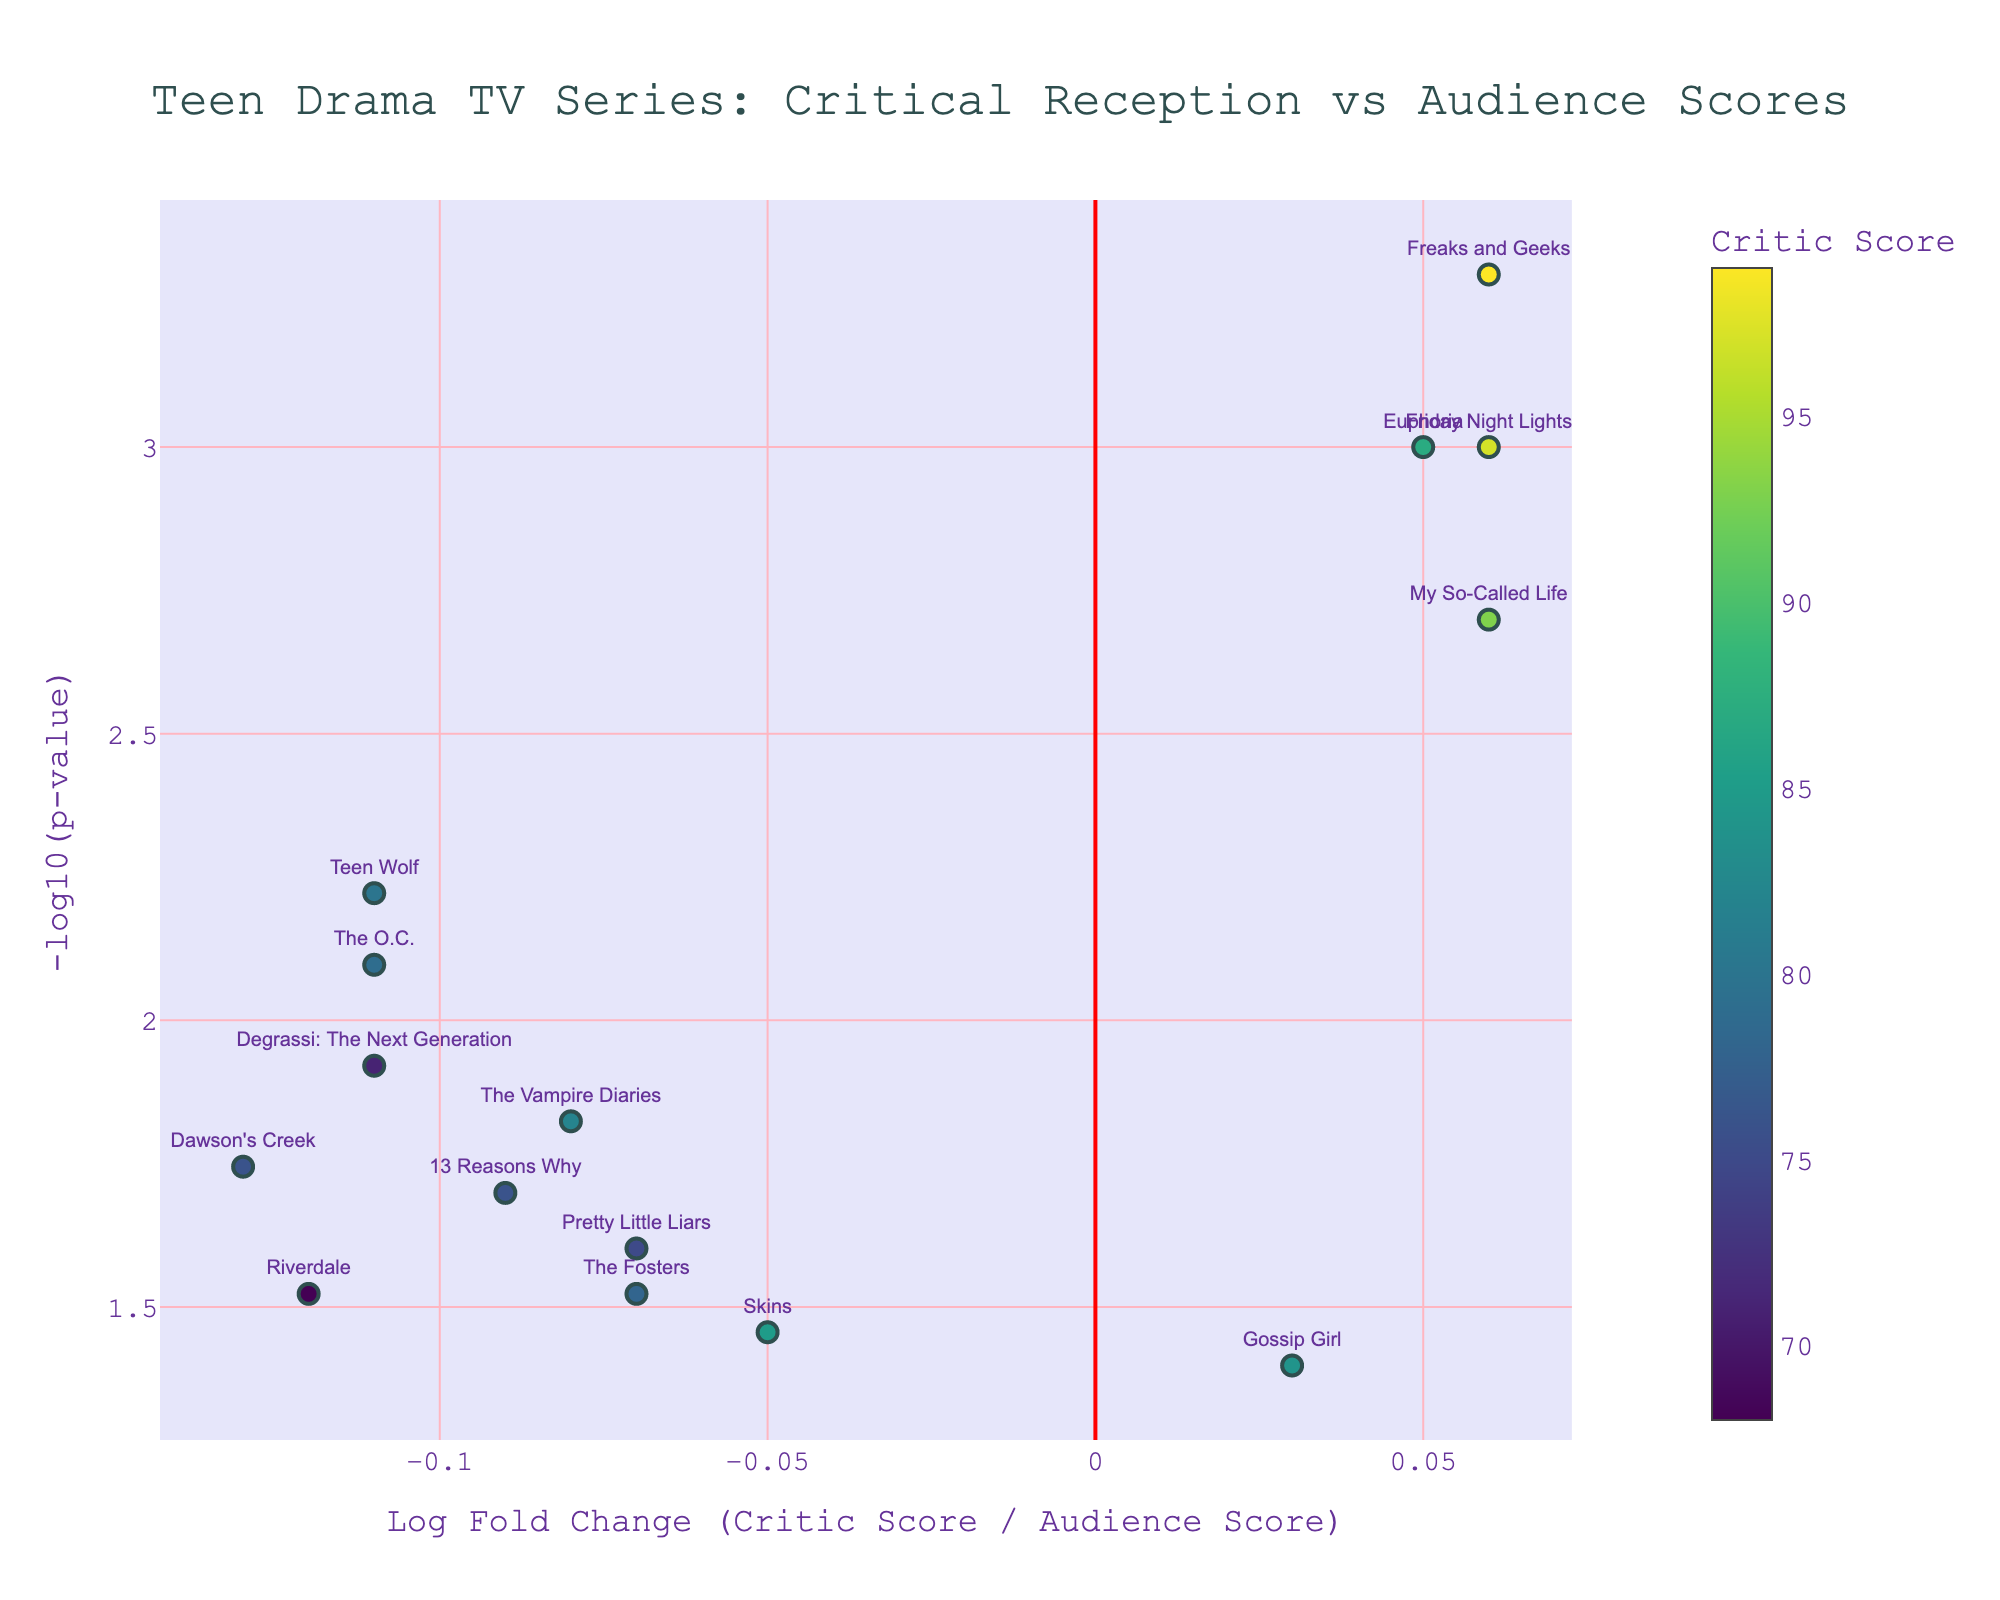What is the title of the figure? The title is located at the top-center of the figure, containing key information about the data being presented. Here, it reads "Teen Drama TV Series: Critical Reception vs Audience Scores"
Answer: Teen Drama TV Series: Critical Reception vs Audience Scores How many data points are shown in the plot? Count the number of markers in the plot which represent each series analyzed. There are markers for Euphoria, 13 Reasons Why, Riverdale, etc.
Answer: 14 What is the x-axis labeled as? The label of the x-axis is written along the horizontal axis at the bottom of the plot. Here, it reads "Log Fold Change (Critic Score / Audience Score)"
Answer: Log Fold Change (Critic Score / Audience Score) What does the y-axis represent? The label of the y-axis is written along the vertical axis on the left side of the plot. It represents "-log10(p-value)", indicating the statistical significance.
Answer: -log10(p-value) Which series has the highest critical score according to the color bar? The color bar on the right side of the plot helps in identifying which series has the highest critical score. The series Freaks and Geeks, marked in bright colors, has the highest critical score of 99.
Answer: Freaks and Geeks What are the audience score and significance for Euphoria? Hover over the marker labeled as Euphoria to find the hover text which includes the audience score and the significance (-log10 of p-value). Here, audience score is 84 and significance is 3.
Answer: Audience Score: 84, Significance: 3 Which series has the largest negative log fold change? Examine the x-axis and identify the marker that is farthest to the left, representing the largest negative log fold change. Dawson's Creek has the largest negative log fold change of -0.13.
Answer: Dawson's Creek Compare the significance of "The Fosters" and "The Vampire Diaries". Which is more statistically significant? Locate the markers for both series on the plot and compare their y-values (significance). The Vampire Diaries, with a higher y-value, is more statistically significant than The Fosters.
Answer: The Vampire Diaries What is the difference in audience scores between "The OC" and "Degrassi: The Next Generation"? Look at the hover text for these two series or refer to the data. The audience score for The OC is 85 and for Degrassi is 77. The difference is 85 - 77 = 8.
Answer: 8 Which series appears to have a better reception by critics than audience but still has a positive audience score on the fold change scale? Check for markers on the right side of the plot (positive log fold change) with positive y-values (significance). Euphoria, My So-Called Life, and Friday Night Lights have such characteristics and Euphoria is notable among them.
Answer: Euphoria 